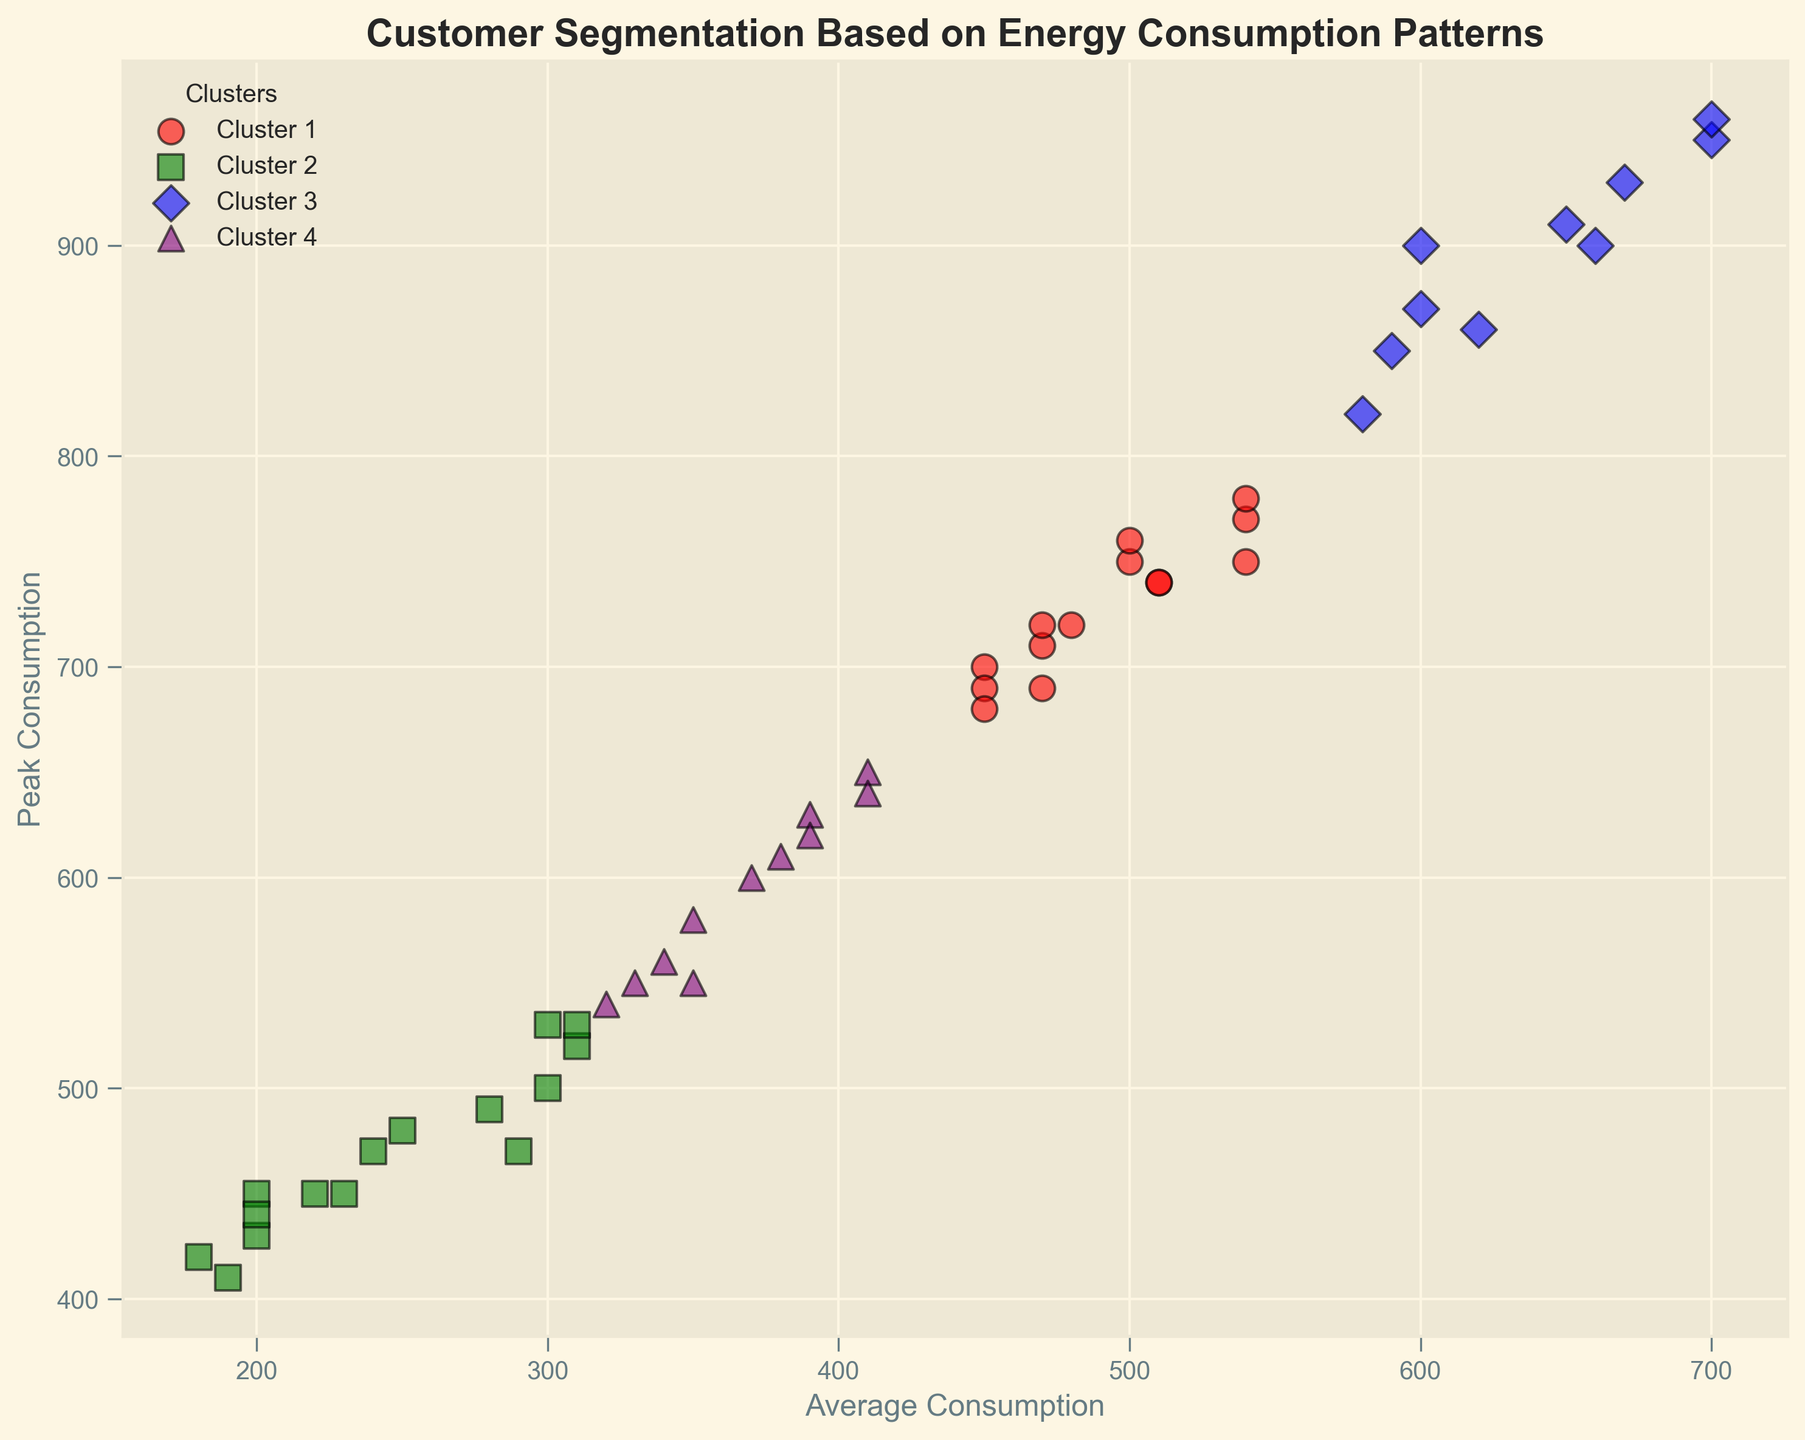Which cluster has the highest average consumption? Look at the scatter plot and identify which cluster has the highest values on the 'Average Consumption' axis. Based on the colors, cluster 3 (blue) has data points with higher average consumption values.
Answer: Cluster 3 Which cluster has the lowest peak consumption? Look at the scatter plot and identify which cluster has the lowest values on the 'Peak Consumption' axis. Based on the colors, cluster 1 (red) has data points with lower peak consumption values.
Answer: Cluster 1 How many clusters are shown in the plot? Count the number of different colors or markers representing distinct clusters in the scatter plot. There are four different clusters, each with a unique color and marker.
Answer: 4 Which two clusters have the most overlapping regions? Examine the scatter plot and compare the regions where data points from different clusters are close to one another. Cluster 1 (red) and Cluster 2 (green) have the most overlapping regions on the plot.
Answer: Cluster 1 and Cluster 2 What is the predominant color for the cluster with the highest peak consumption? Identify the cluster with the highest values on the 'Peak Consumption' axis and observe its color. The cluster with the highest peak consumption is Cluster 4 (purple).
Answer: Purple Between Cluster 2 and Cluster 3, which one shows a higher range of average consumption values? Compare the spread of data points along the 'Average Consumption' axis for Cluster 2 (green) and Cluster 3 (blue). Cluster 3 (blue) has a wider range of average consumption values.
Answer: Cluster 3 What is the visual representation (color and marker) of the cluster with the second lowest standard deviation? Identify the color and marker of the cluster that has the second lowest standard deviation of the data points visualized. The cluster with the second lowest standard deviation is Cluster 4 (purple) represented with a triangle (^).
Answer: Purple, Triangle Compare the average consumption between Cluster 1 and Cluster 4. Which one tends to consume more on average? Observe the data points' positions along the 'Average Consumption' axis for Cluster 1 (red) and Cluster 4 (purple) and compare their range and central tendency. Cluster 4 (purple) tends to consume more on average.
Answer: Cluster 4 Which two clusters have the least number of overlapping data points? Determine the clusters whose data points are most spatially separated from each other on both 'Average Consumption' and 'Peak Consumption' axes. Cluster 3 (blue) and Cluster 4 (purple) have the least overlap in their data points.
Answer: Cluster 3 and Cluster 4 